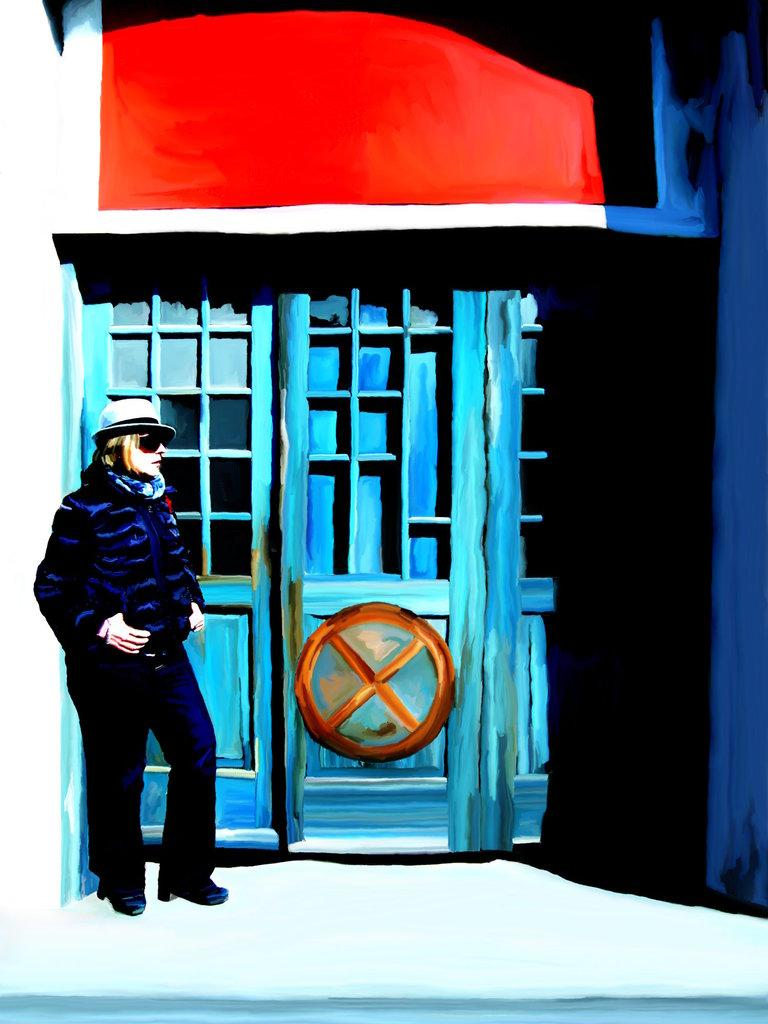What type of artwork is depicted in the image? The image is a painting. Who or what is the main subject of the painting? There is a girl in the painting. Where is the girl positioned in the painting? The girl is standing in front of a building. What type of tub can be seen in the painting? There is no tub present in the painting; it features a girl standing in front of a building. Does the girl have a brother in the painting? The provided facts do not mention the presence of a brother in the painting. 